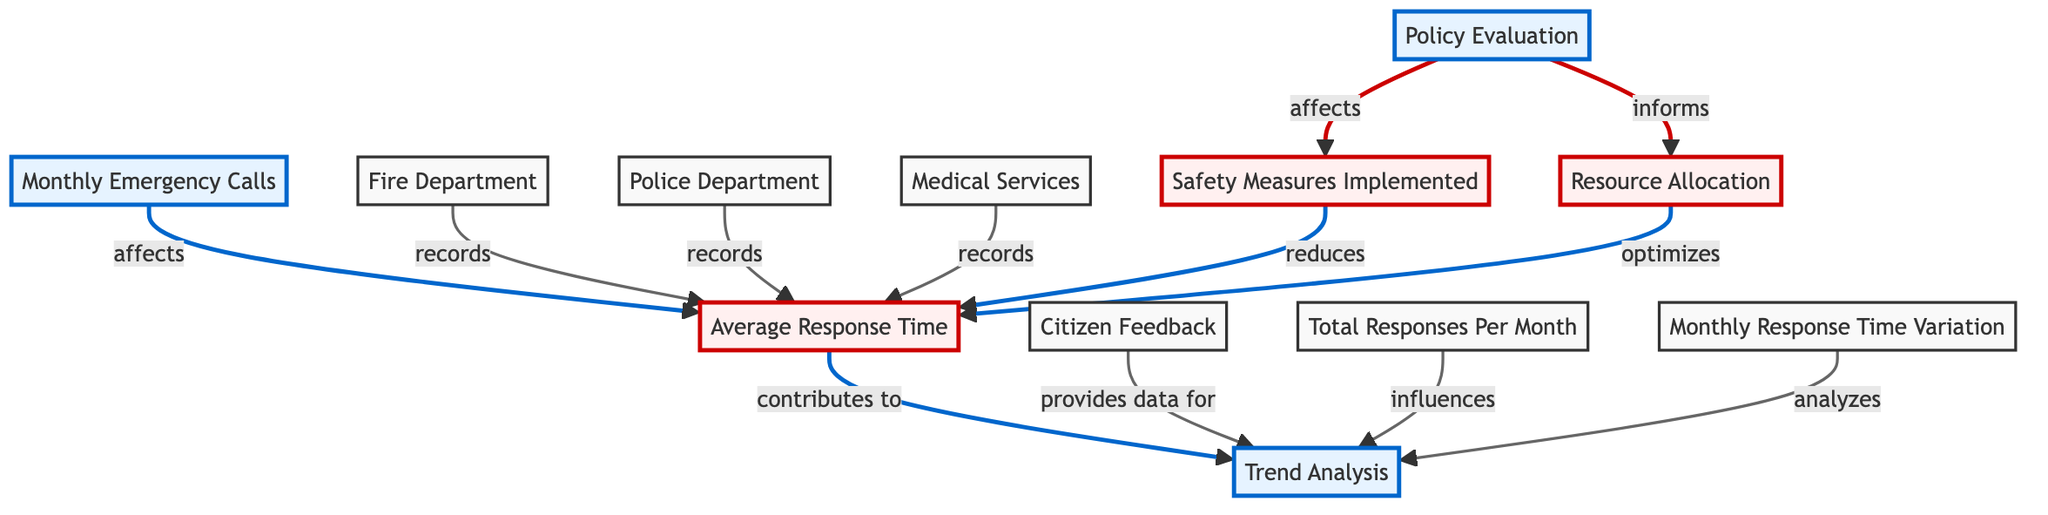what is the first node in the flow? The first node in the flow of the diagram is "Monthly Emergency Calls", as it is the initial point that affects other components in the analysis.
Answer: Monthly Emergency Calls how many departments record response time? Three departments are mentioned in the diagram: Fire Department, Police Department, and Medical Services, all of which record response time.
Answer: Three which element reduces response time? The "Safety Measures Implemented" element is indicated to reduce response time in the analysis.
Answer: Safety Measures Implemented what affects safety measures? The "Policy Evaluation" affects safety measures, as it informs how safety measures are implemented and evaluated in response to emergencies.
Answer: Policy Evaluation how does citizen feedback contribute to the analysis? Citizen feedback provides data for "Trend Analysis", which is crucial for understanding patterns in response times and improving services.
Answer: Provides data for what influences trend analysis? The trend analysis is influenced by various factors including total responses per month, monthly response time variation, and citizen feedback among others.
Answer: Total Responses Per Month, Monthly Response Time Variation, Citizen Feedback which node implements resource allocation? The "Policy Evaluation" impacts the resource allocation process, determining how resources are allocated based on response times and other factors.
Answer: Policy Evaluation how does resource allocation affect response time? Resource allocation optimizes response time by ensuring that the necessary resources are properly distributed to respond to emergencies more efficiently.
Answer: Optimizes what does response time contribute to? The average response time contributes to the trend analysis, which analyzes the data over the year to evaluate performance and identify areas for improvement.
Answer: Trend Analysis 